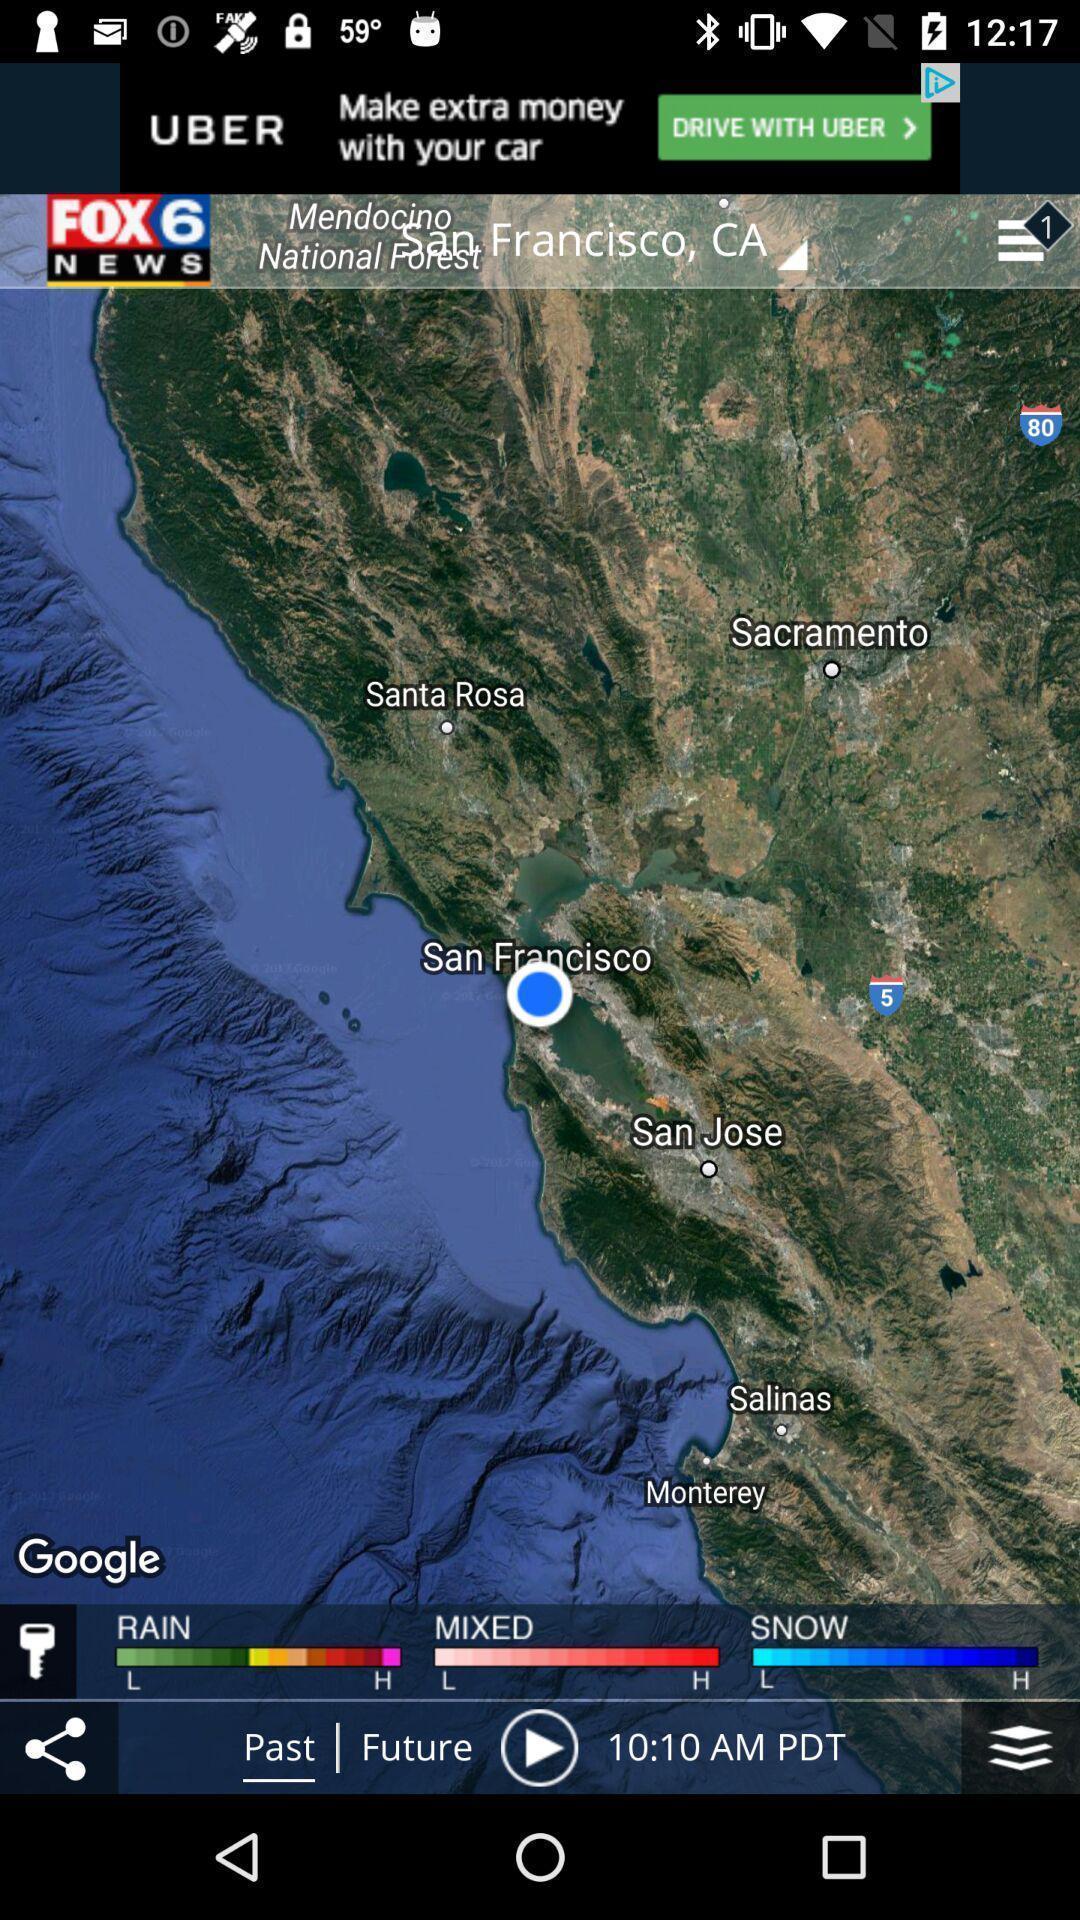Tell me what you see in this picture. Window displaying an weather app. 